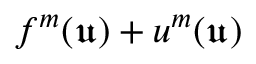<formula> <loc_0><loc_0><loc_500><loc_500>f ^ { m } ( \mathfrak { u } ) + u ^ { m } ( \mathfrak { u } )</formula> 